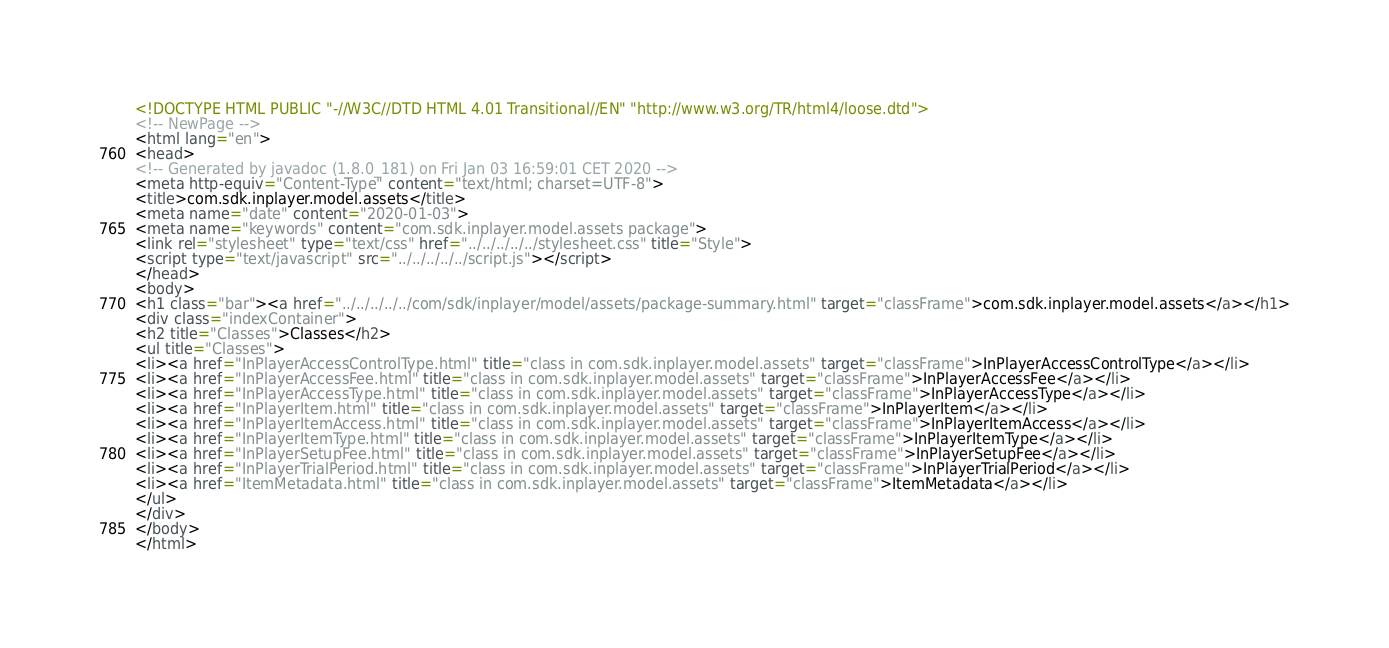<code> <loc_0><loc_0><loc_500><loc_500><_HTML_><!DOCTYPE HTML PUBLIC "-//W3C//DTD HTML 4.01 Transitional//EN" "http://www.w3.org/TR/html4/loose.dtd">
<!-- NewPage -->
<html lang="en">
<head>
<!-- Generated by javadoc (1.8.0_181) on Fri Jan 03 16:59:01 CET 2020 -->
<meta http-equiv="Content-Type" content="text/html; charset=UTF-8">
<title>com.sdk.inplayer.model.assets</title>
<meta name="date" content="2020-01-03">
<meta name="keywords" content="com.sdk.inplayer.model.assets package">
<link rel="stylesheet" type="text/css" href="../../../../../stylesheet.css" title="Style">
<script type="text/javascript" src="../../../../../script.js"></script>
</head>
<body>
<h1 class="bar"><a href="../../../../../com/sdk/inplayer/model/assets/package-summary.html" target="classFrame">com.sdk.inplayer.model.assets</a></h1>
<div class="indexContainer">
<h2 title="Classes">Classes</h2>
<ul title="Classes">
<li><a href="InPlayerAccessControlType.html" title="class in com.sdk.inplayer.model.assets" target="classFrame">InPlayerAccessControlType</a></li>
<li><a href="InPlayerAccessFee.html" title="class in com.sdk.inplayer.model.assets" target="classFrame">InPlayerAccessFee</a></li>
<li><a href="InPlayerAccessType.html" title="class in com.sdk.inplayer.model.assets" target="classFrame">InPlayerAccessType</a></li>
<li><a href="InPlayerItem.html" title="class in com.sdk.inplayer.model.assets" target="classFrame">InPlayerItem</a></li>
<li><a href="InPlayerItemAccess.html" title="class in com.sdk.inplayer.model.assets" target="classFrame">InPlayerItemAccess</a></li>
<li><a href="InPlayerItemType.html" title="class in com.sdk.inplayer.model.assets" target="classFrame">InPlayerItemType</a></li>
<li><a href="InPlayerSetupFee.html" title="class in com.sdk.inplayer.model.assets" target="classFrame">InPlayerSetupFee</a></li>
<li><a href="InPlayerTrialPeriod.html" title="class in com.sdk.inplayer.model.assets" target="classFrame">InPlayerTrialPeriod</a></li>
<li><a href="ItemMetadata.html" title="class in com.sdk.inplayer.model.assets" target="classFrame">ItemMetadata</a></li>
</ul>
</div>
</body>
</html>
</code> 